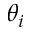Convert formula to latex. <formula><loc_0><loc_0><loc_500><loc_500>\theta _ { i }</formula> 